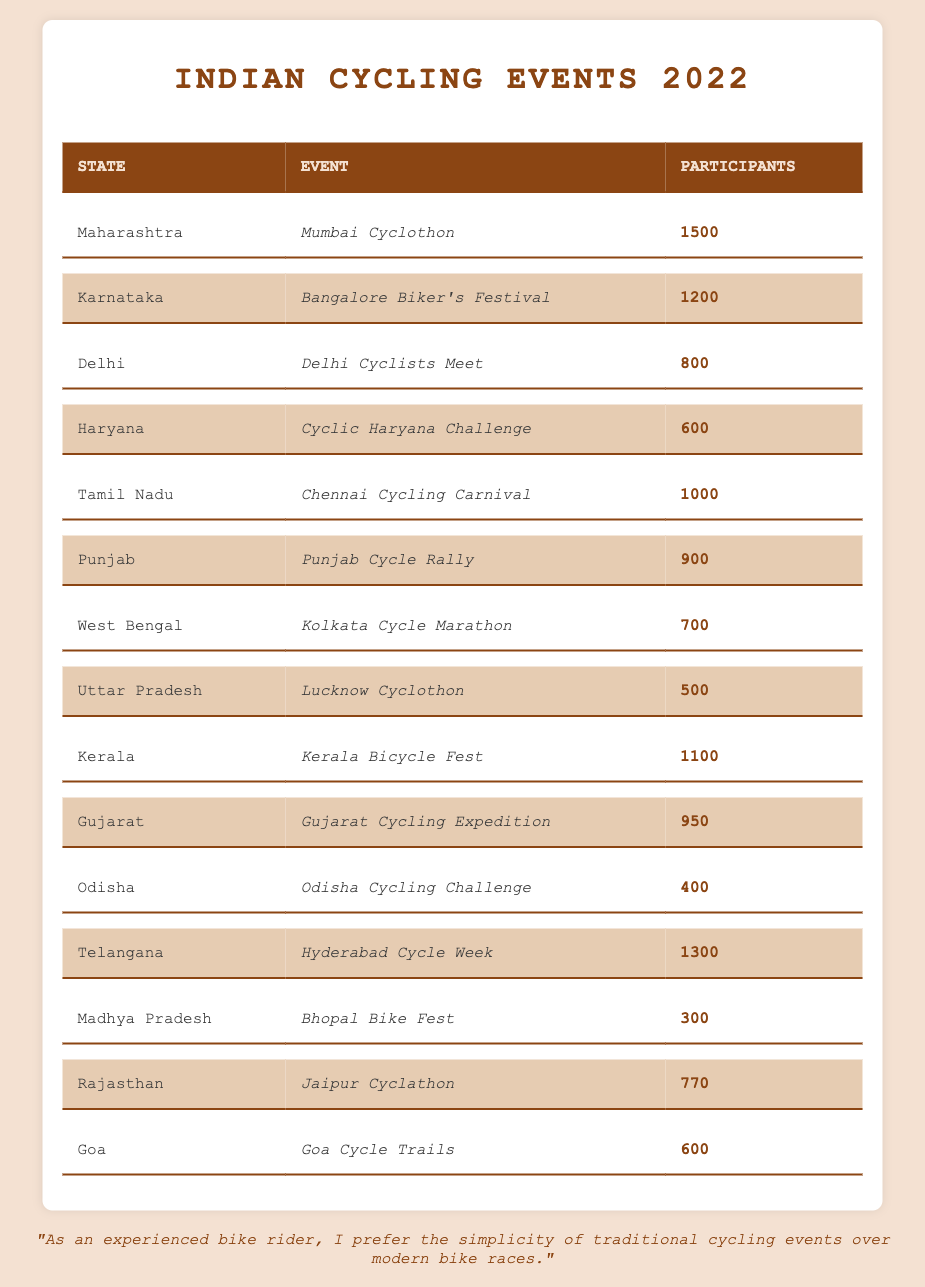What was the total number of participants in all cycling events across India in 2022? To find the total number of participants, we add the participants from each event listed: 1500 + 1200 + 800 + 600 + 1000 + 900 + 700 + 500 + 1100 + 950 + 400 + 1300 + 300 + 770 + 600 = 10070.
Answer: 10070 Which state had the highest number of participants in their cycling event? By reviewing the participants in each state, we see that Maharashtra had the highest with 1500 participants in the Mumbai Cyclothon.
Answer: Maharashtra How many states had more than 1000 participants? Looking at the table, the states with more than 1000 participants are Maharashtra (1500), Karnataka (1200), Telangana (1300), and Kerala (1100). That's four states.
Answer: 4 What is the average number of participants across all events? To find the average, we add all participants (10070) and divide by the number of events (15): 10070 / 15 = 671.33.
Answer: Approximately 671 Which event had the least number of participants, and how many participated? From the table, we can see that the Odisha Cycling Challenge had the least participants with a total of 400.
Answer: Odisha Cycling Challenge, 400 Is it true that Delhi had more participants than Haryana? Delhi had 800 participants while Haryana had 600, so it is true.
Answer: Yes If we exclude the top three events with the highest participants, what is the total for the remaining events? After excluding the top three (Maharashtra, Karnataka, and Telangana totaling 1500 + 1200 + 1300 = 4000), we add the remaining events: 800 + 600 + 1000 + 900 + 700 + 500 + 1100 + 950 + 400 + 300 + 770 + 600 = 7350.
Answer: 7350 What is the difference in participants between the highest and lowest attended cycling events? The highest attended was Maharashtra with 1500 and the lowest was Odisha with 400. Thus, the difference is 1500 - 400 = 1100.
Answer: 1100 Which state had a cycling event with exactly 600 participants? Both Haryana with the Cyclic Haryana Challenge and Goa with Goa Cycle Trails had 600 participants.
Answer: Haryana and Goa 